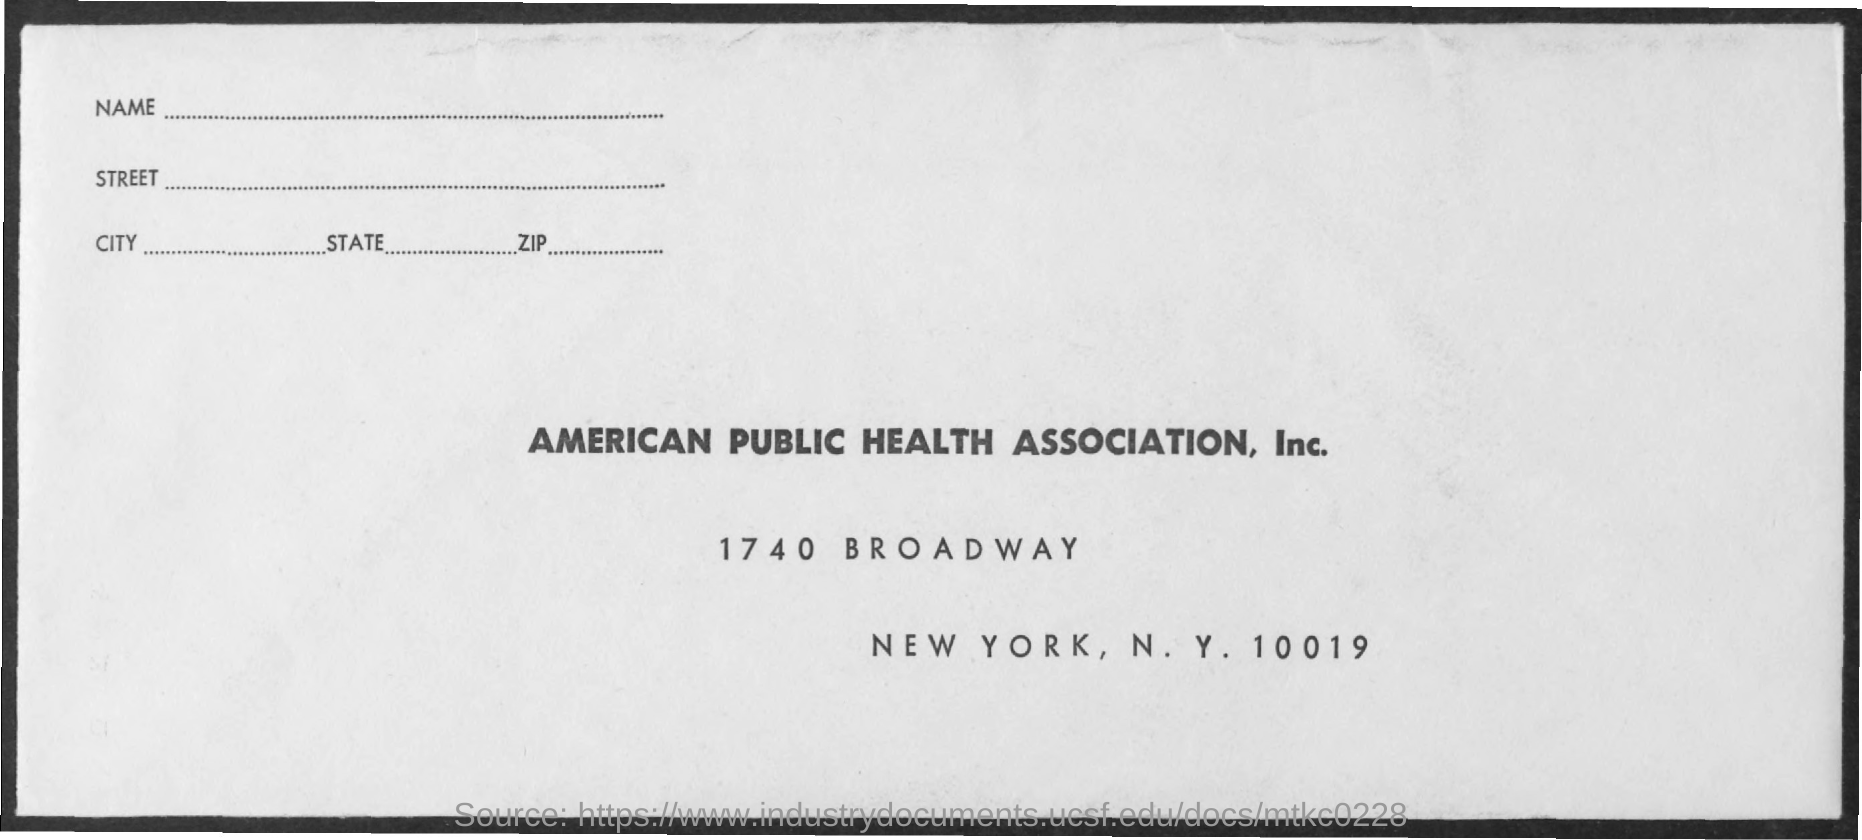What is the name of the health association ?
Provide a succinct answer. AMERICAN PUBLIC HEALTH ASSOCIATION, INC. Which city is mentioned in the document ?
Keep it short and to the point. NEW YORK. 